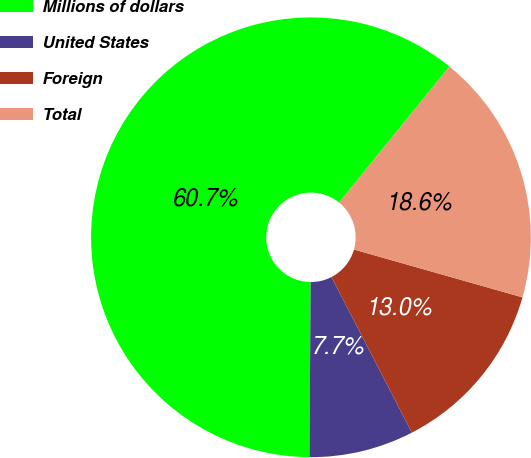Convert chart. <chart><loc_0><loc_0><loc_500><loc_500><pie_chart><fcel>Millions of dollars<fcel>United States<fcel>Foreign<fcel>Total<nl><fcel>60.74%<fcel>7.7%<fcel>13.01%<fcel>18.56%<nl></chart> 